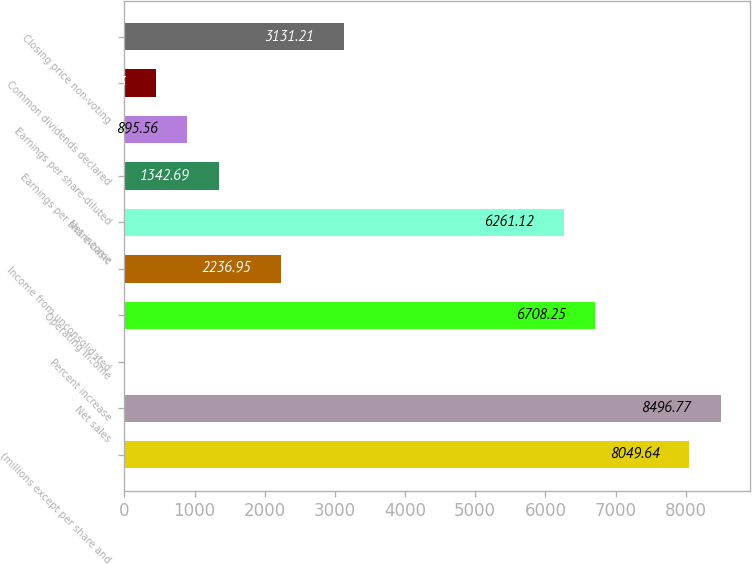<chart> <loc_0><loc_0><loc_500><loc_500><bar_chart><fcel>(millions except per share and<fcel>Net sales<fcel>Percent increase<fcel>Operating income<fcel>Income from unconsolidated<fcel>Net income<fcel>Earnings per share-basic<fcel>Earnings per share-diluted<fcel>Common dividends declared<fcel>Closing price non-voting<nl><fcel>8049.64<fcel>8496.77<fcel>1.3<fcel>6708.25<fcel>2236.95<fcel>6261.12<fcel>1342.69<fcel>895.56<fcel>448.43<fcel>3131.21<nl></chart> 